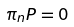Convert formula to latex. <formula><loc_0><loc_0><loc_500><loc_500>\pi _ { n } P = 0</formula> 